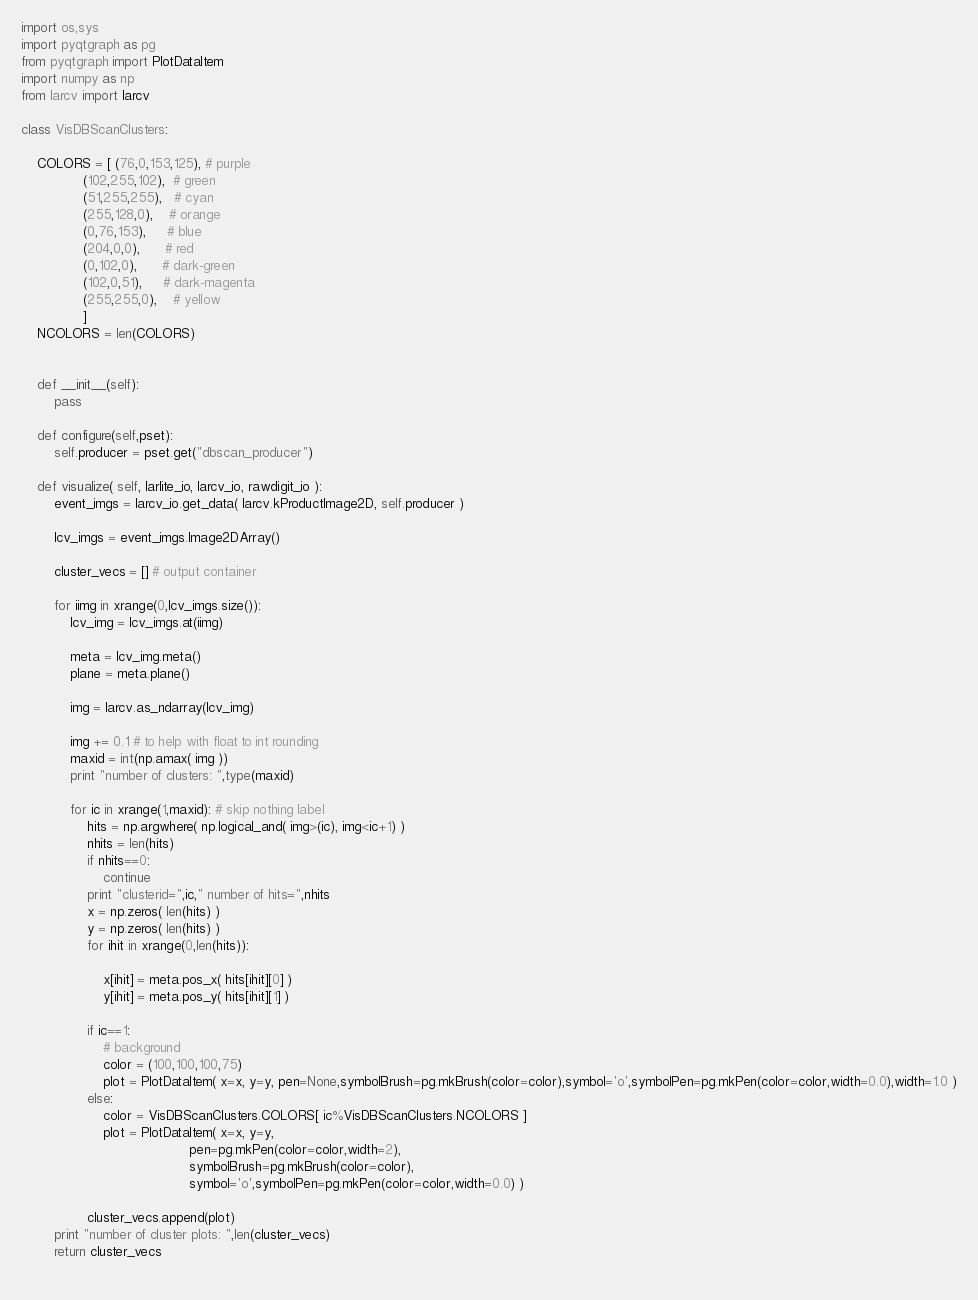<code> <loc_0><loc_0><loc_500><loc_500><_Python_>import os,sys
import pyqtgraph as pg
from pyqtgraph import PlotDataItem
import numpy as np
from larcv import larcv

class VisDBScanClusters:

    COLORS = [ (76,0,153,125), # purple
               (102,255,102),  # green
               (51,255,255),   # cyan
               (255,128,0),    # orange
               (0,76,153),     # blue
               (204,0,0),      # red
               (0,102,0),      # dark-green
               (102,0,51),     # dark-magenta
               (255,255,0),    # yellow
               ]
    NCOLORS = len(COLORS)
               
    
    def __init__(self):
        pass

    def configure(self,pset):
        self.producer = pset.get("dbscan_producer")

    def visualize( self, larlite_io, larcv_io, rawdigit_io ):
        event_imgs = larcv_io.get_data( larcv.kProductImage2D, self.producer )

        lcv_imgs = event_imgs.Image2DArray()

        cluster_vecs = [] # output container

        for iimg in xrange(0,lcv_imgs.size()):
            lcv_img = lcv_imgs.at(iimg)

            meta = lcv_img.meta()
            plane = meta.plane()
        
            img = larcv.as_ndarray(lcv_img)

            img += 0.1 # to help with float to int rounding
            maxid = int(np.amax( img ))
            print "number of clusters: ",type(maxid)

            for ic in xrange(1,maxid): # skip nothing label
                hits = np.argwhere( np.logical_and( img>(ic), img<ic+1) )
                nhits = len(hits)
                if nhits==0:
                    continue
                print "clusterid=",ic," number of hits=",nhits
                x = np.zeros( len(hits) )
                y = np.zeros( len(hits) )
                for ihit in xrange(0,len(hits)):

                    x[ihit] = meta.pos_x( hits[ihit][0] )
                    y[ihit] = meta.pos_y( hits[ihit][1] )
            
                if ic==1:
                    # background
                    color = (100,100,100,75)
                    plot = PlotDataItem( x=x, y=y, pen=None,symbolBrush=pg.mkBrush(color=color),symbol='o',symbolPen=pg.mkPen(color=color,width=0.0),width=1.0 )
                else:
                    color = VisDBScanClusters.COLORS[ ic%VisDBScanClusters.NCOLORS ]
                    plot = PlotDataItem( x=x, y=y, 
                                         pen=pg.mkPen(color=color,width=2),
                                         symbolBrush=pg.mkBrush(color=color),
                                         symbol='o',symbolPen=pg.mkPen(color=color,width=0.0) )

                cluster_vecs.append(plot)
        print "number of cluster plots: ",len(cluster_vecs)
        return cluster_vecs
            
</code> 